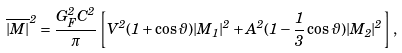Convert formula to latex. <formula><loc_0><loc_0><loc_500><loc_500>\overline { | M | } ^ { 2 } = \frac { G _ { F } ^ { 2 } C ^ { 2 } } { \pi } \left [ V ^ { 2 } ( 1 + \cos \vartheta ) | M _ { 1 } | ^ { 2 } + A ^ { 2 } ( 1 - \frac { 1 } { 3 } \cos \vartheta ) | M _ { 2 } | ^ { 2 } \right ] ,</formula> 